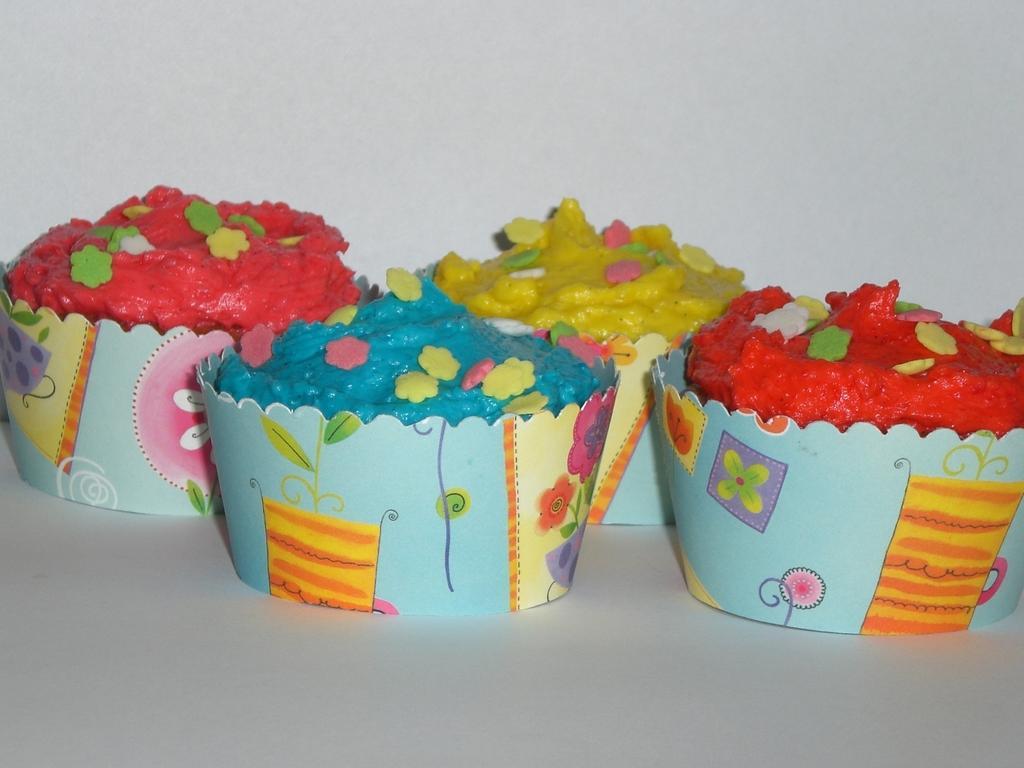Describe this image in one or two sentences. In the image in the center we can see one table. On the table,we can see four cupcakes in different colors. In the background there is a wall. 